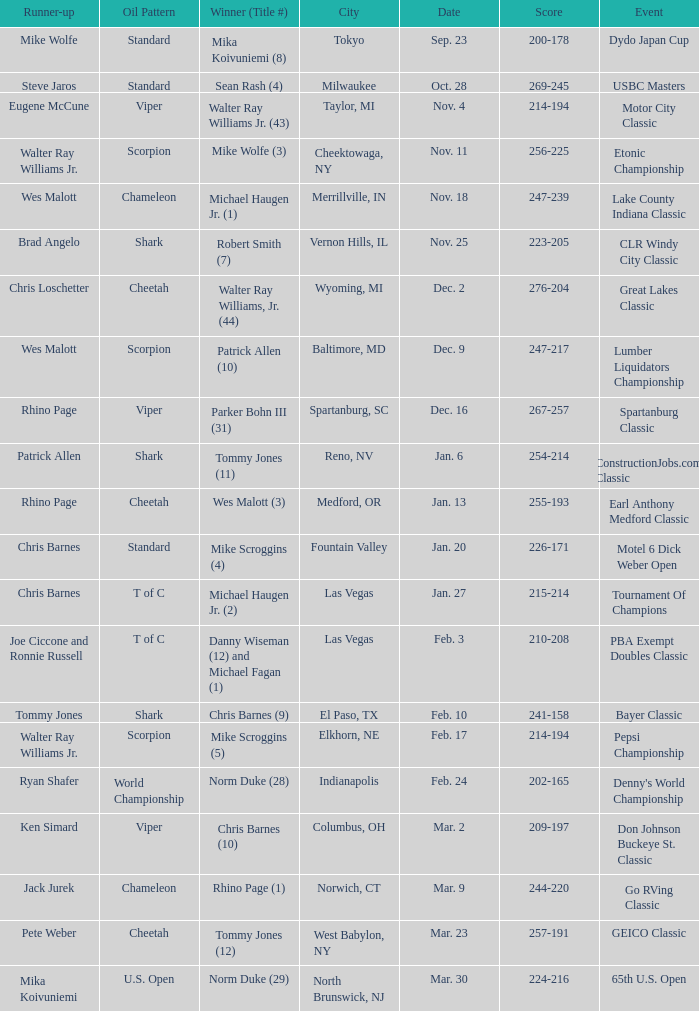Write the full table. {'header': ['Runner-up', 'Oil Pattern', 'Winner (Title #)', 'City', 'Date', 'Score', 'Event'], 'rows': [['Mike Wolfe', 'Standard', 'Mika Koivuniemi (8)', 'Tokyo', 'Sep. 23', '200-178', 'Dydo Japan Cup'], ['Steve Jaros', 'Standard', 'Sean Rash (4)', 'Milwaukee', 'Oct. 28', '269-245', 'USBC Masters'], ['Eugene McCune', 'Viper', 'Walter Ray Williams Jr. (43)', 'Taylor, MI', 'Nov. 4', '214-194', 'Motor City Classic'], ['Walter Ray Williams Jr.', 'Scorpion', 'Mike Wolfe (3)', 'Cheektowaga, NY', 'Nov. 11', '256-225', 'Etonic Championship'], ['Wes Malott', 'Chameleon', 'Michael Haugen Jr. (1)', 'Merrillville, IN', 'Nov. 18', '247-239', 'Lake County Indiana Classic'], ['Brad Angelo', 'Shark', 'Robert Smith (7)', 'Vernon Hills, IL', 'Nov. 25', '223-205', 'CLR Windy City Classic'], ['Chris Loschetter', 'Cheetah', 'Walter Ray Williams, Jr. (44)', 'Wyoming, MI', 'Dec. 2', '276-204', 'Great Lakes Classic'], ['Wes Malott', 'Scorpion', 'Patrick Allen (10)', 'Baltimore, MD', 'Dec. 9', '247-217', 'Lumber Liquidators Championship'], ['Rhino Page', 'Viper', 'Parker Bohn III (31)', 'Spartanburg, SC', 'Dec. 16', '267-257', 'Spartanburg Classic'], ['Patrick Allen', 'Shark', 'Tommy Jones (11)', 'Reno, NV', 'Jan. 6', '254-214', 'ConstructionJobs.com Classic'], ['Rhino Page', 'Cheetah', 'Wes Malott (3)', 'Medford, OR', 'Jan. 13', '255-193', 'Earl Anthony Medford Classic'], ['Chris Barnes', 'Standard', 'Mike Scroggins (4)', 'Fountain Valley', 'Jan. 20', '226-171', 'Motel 6 Dick Weber Open'], ['Chris Barnes', 'T of C', 'Michael Haugen Jr. (2)', 'Las Vegas', 'Jan. 27', '215-214', 'Tournament Of Champions'], ['Joe Ciccone and Ronnie Russell', 'T of C', 'Danny Wiseman (12) and Michael Fagan (1)', 'Las Vegas', 'Feb. 3', '210-208', 'PBA Exempt Doubles Classic'], ['Tommy Jones', 'Shark', 'Chris Barnes (9)', 'El Paso, TX', 'Feb. 10', '241-158', 'Bayer Classic'], ['Walter Ray Williams Jr.', 'Scorpion', 'Mike Scroggins (5)', 'Elkhorn, NE', 'Feb. 17', '214-194', 'Pepsi Championship'], ['Ryan Shafer', 'World Championship', 'Norm Duke (28)', 'Indianapolis', 'Feb. 24', '202-165', "Denny's World Championship"], ['Ken Simard', 'Viper', 'Chris Barnes (10)', 'Columbus, OH', 'Mar. 2', '209-197', 'Don Johnson Buckeye St. Classic'], ['Jack Jurek', 'Chameleon', 'Rhino Page (1)', 'Norwich, CT', 'Mar. 9', '244-220', 'Go RVing Classic'], ['Pete Weber', 'Cheetah', 'Tommy Jones (12)', 'West Babylon, NY', 'Mar. 23', '257-191', 'GEICO Classic'], ['Mika Koivuniemi', 'U.S. Open', 'Norm Duke (29)', 'North Brunswick, NJ', 'Mar. 30', '224-216', '65th U.S. Open']]} Name the Date which has a Oil Pattern of chameleon, and a Event of lake county indiana classic? Nov. 18. 